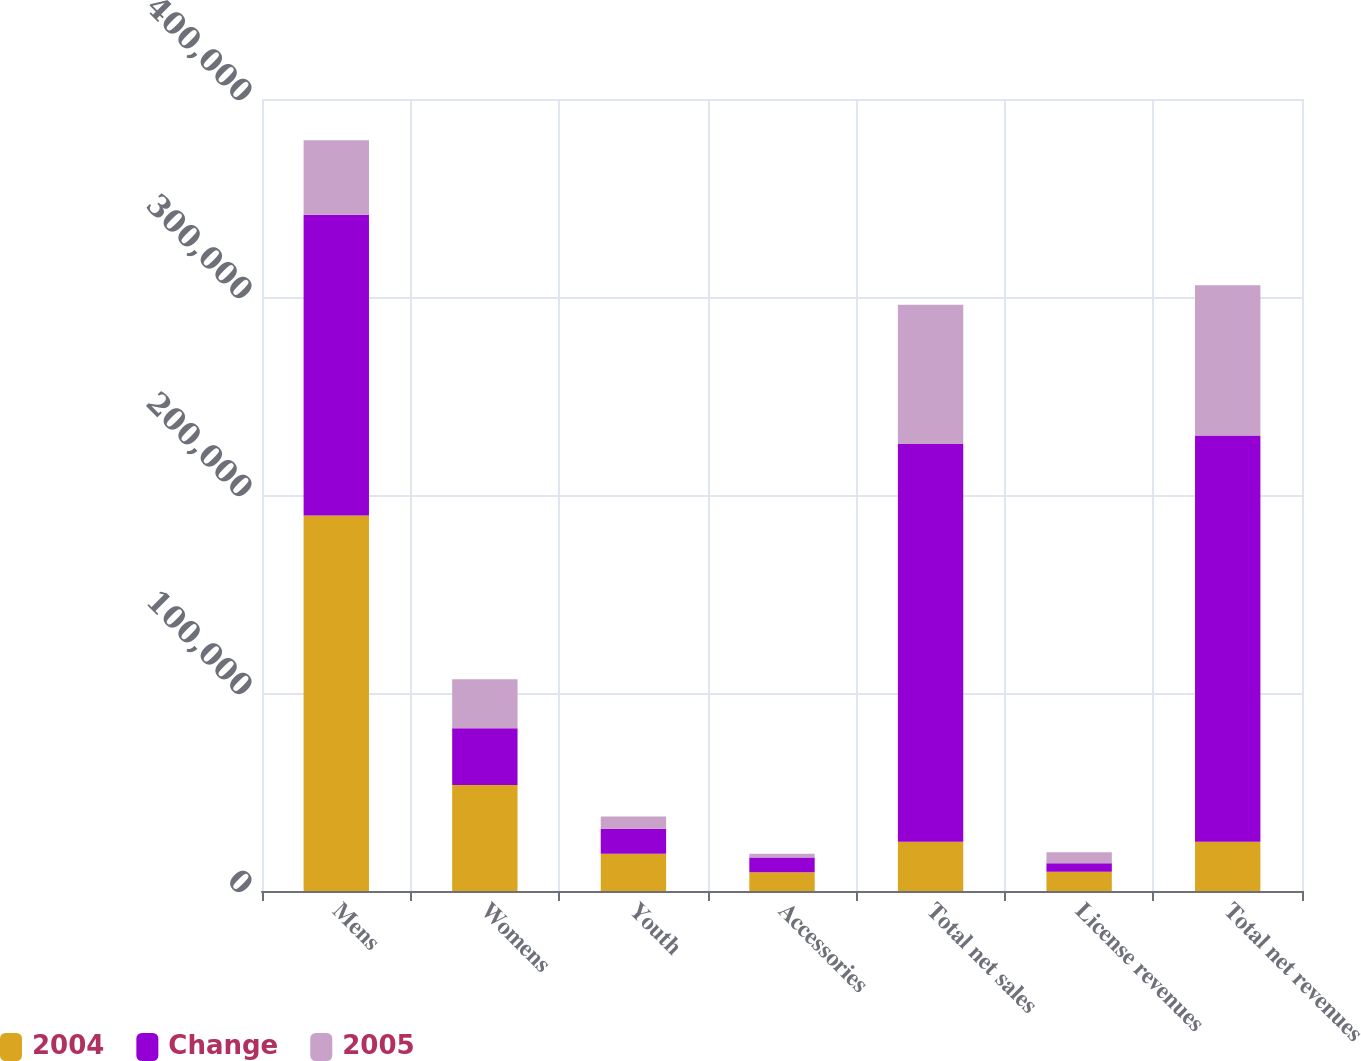Convert chart to OTSL. <chart><loc_0><loc_0><loc_500><loc_500><stacked_bar_chart><ecel><fcel>Mens<fcel>Womens<fcel>Youth<fcel>Accessories<fcel>Total net sales<fcel>License revenues<fcel>Total net revenues<nl><fcel>2004<fcel>189596<fcel>53500<fcel>18784<fcel>9409<fcel>24841<fcel>9764<fcel>24841<nl><fcel>Change<fcel>151962<fcel>28659<fcel>12705<fcel>7548<fcel>200874<fcel>4307<fcel>205181<nl><fcel>2005<fcel>37634<fcel>24841<fcel>6079<fcel>1861<fcel>70415<fcel>5457<fcel>75872<nl></chart> 